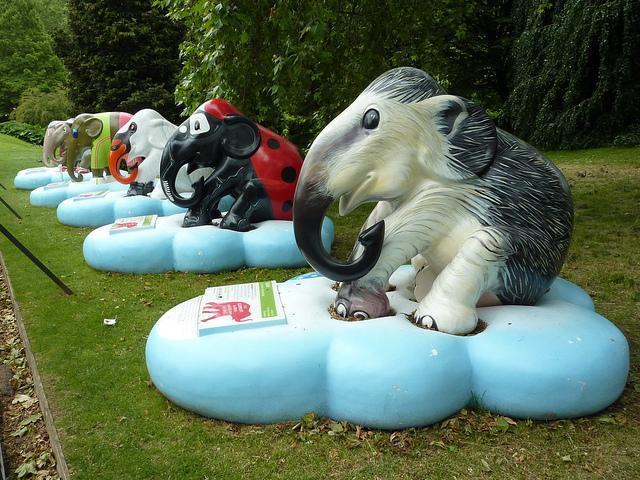How many sculptures are there?
Give a very brief answer. 5. How many elephants are there?
Give a very brief answer. 4. 